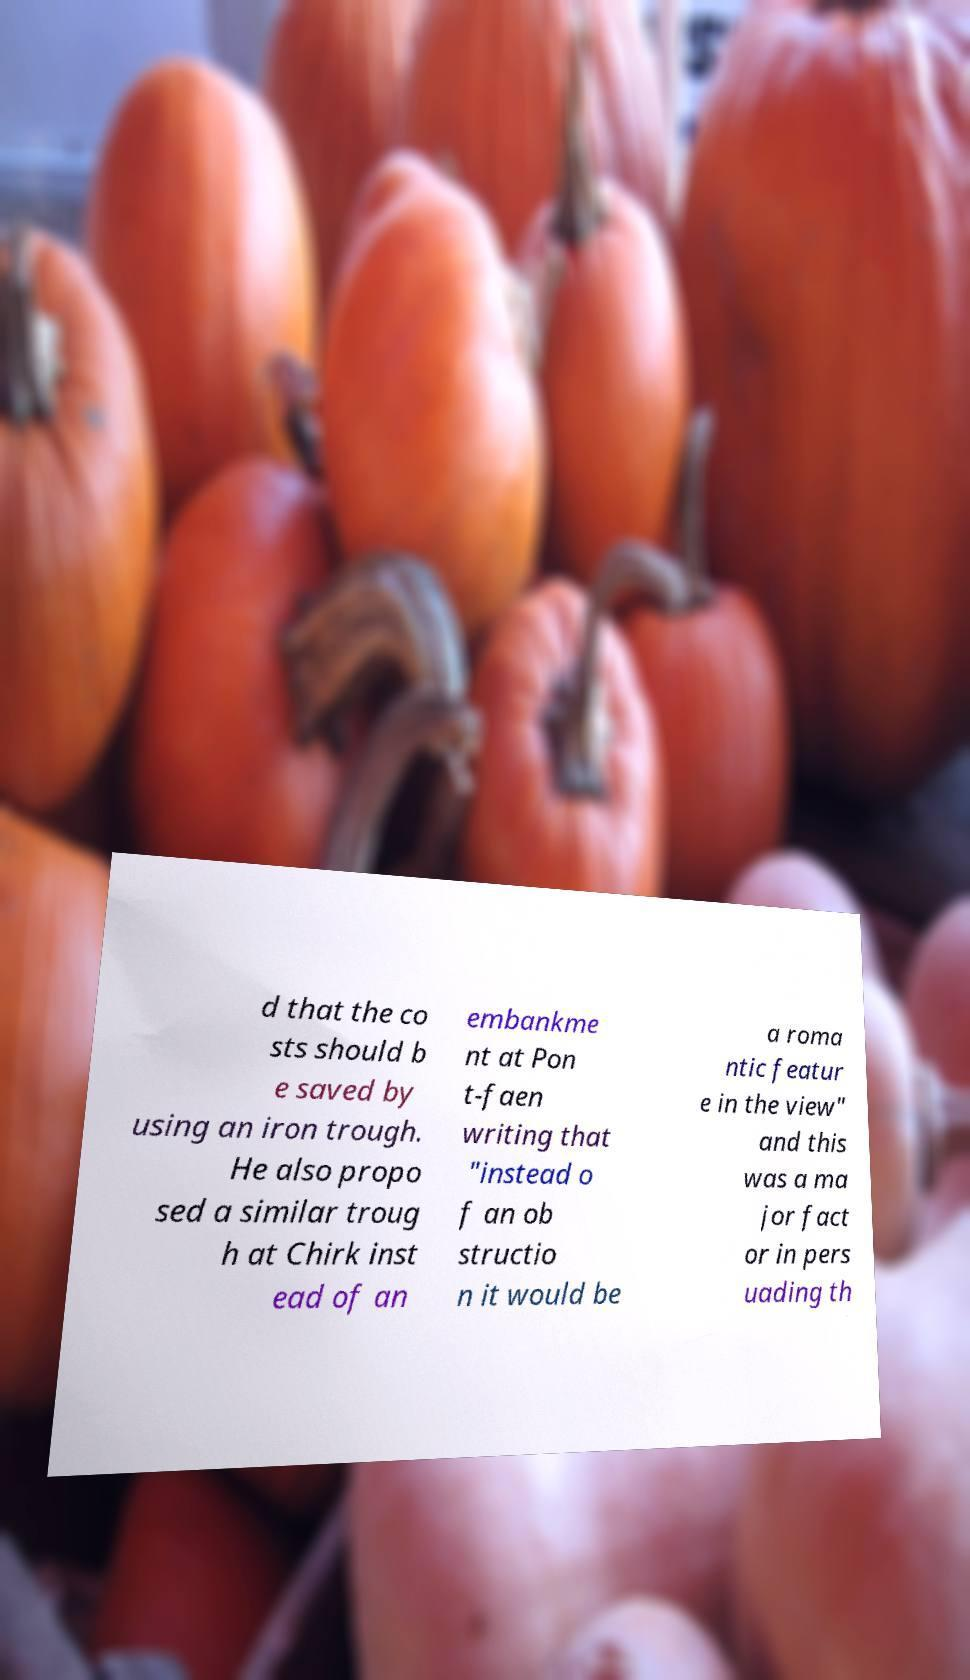What messages or text are displayed in this image? I need them in a readable, typed format. d that the co sts should b e saved by using an iron trough. He also propo sed a similar troug h at Chirk inst ead of an embankme nt at Pon t-faen writing that "instead o f an ob structio n it would be a roma ntic featur e in the view" and this was a ma jor fact or in pers uading th 